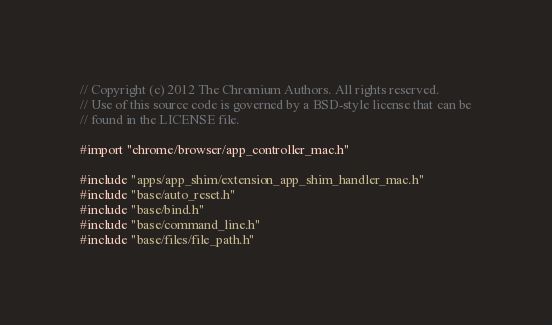Convert code to text. <code><loc_0><loc_0><loc_500><loc_500><_ObjectiveC_>// Copyright (c) 2012 The Chromium Authors. All rights reserved.
// Use of this source code is governed by a BSD-style license that can be
// found in the LICENSE file.

#import "chrome/browser/app_controller_mac.h"

#include "apps/app_shim/extension_app_shim_handler_mac.h"
#include "base/auto_reset.h"
#include "base/bind.h"
#include "base/command_line.h"
#include "base/files/file_path.h"</code> 